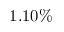<formula> <loc_0><loc_0><loc_500><loc_500>1 . 1 0 \%</formula> 